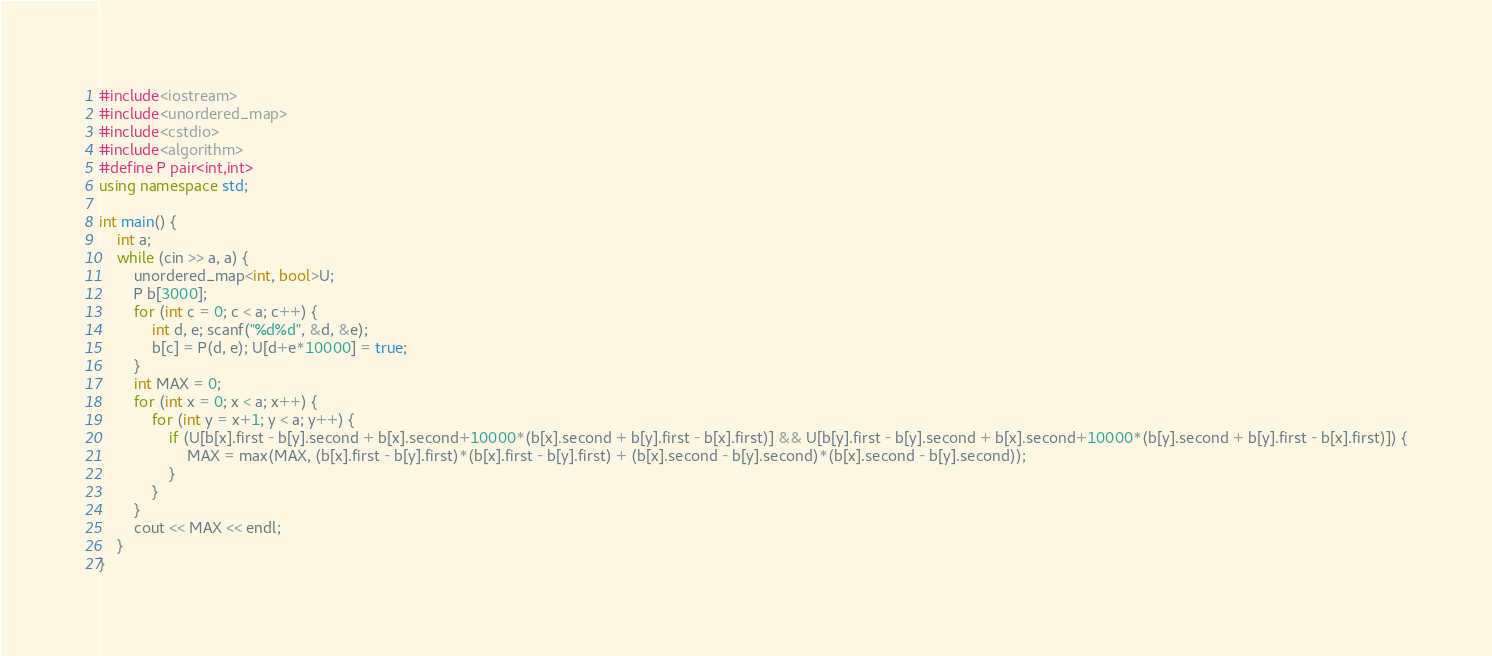<code> <loc_0><loc_0><loc_500><loc_500><_C++_>#include<iostream>
#include<unordered_map>
#include<cstdio>
#include<algorithm>
#define P pair<int,int>
using namespace std;

int main() {
	int a;
	while (cin >> a, a) {
		unordered_map<int, bool>U;
		P b[3000];
		for (int c = 0; c < a; c++) {
			int d, e; scanf("%d%d", &d, &e);
			b[c] = P(d, e); U[d+e*10000] = true;
		}
		int MAX = 0;
		for (int x = 0; x < a; x++) {
			for (int y = x+1; y < a; y++) {
				if (U[b[x].first - b[y].second + b[x].second+10000*(b[x].second + b[y].first - b[x].first)] && U[b[y].first - b[y].second + b[x].second+10000*(b[y].second + b[y].first - b[x].first)]) {
					MAX = max(MAX, (b[x].first - b[y].first)*(b[x].first - b[y].first) + (b[x].second - b[y].second)*(b[x].second - b[y].second));
				}
			}
		}
		cout << MAX << endl;
	}
}</code> 